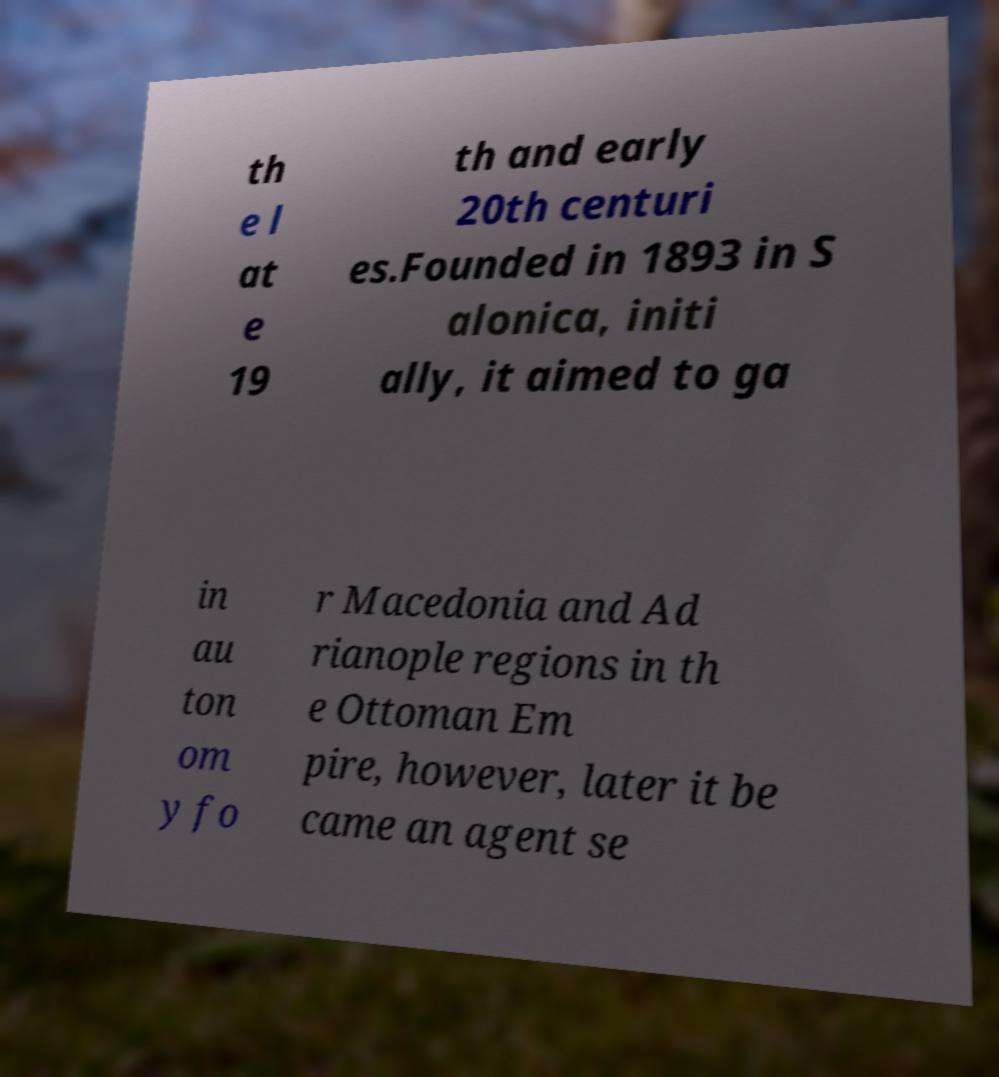Could you assist in decoding the text presented in this image and type it out clearly? th e l at e 19 th and early 20th centuri es.Founded in 1893 in S alonica, initi ally, it aimed to ga in au ton om y fo r Macedonia and Ad rianople regions in th e Ottoman Em pire, however, later it be came an agent se 